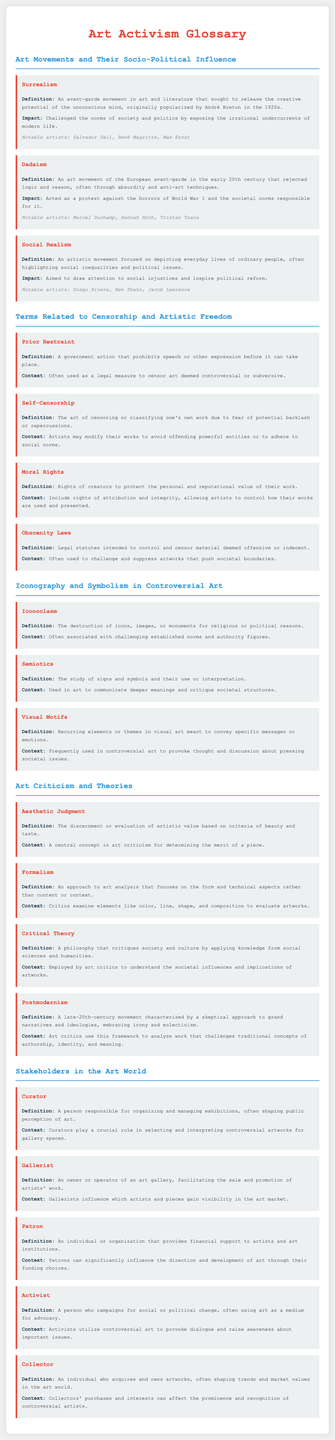What is the definition of Dadaism? Dadaism is defined as an art movement of the European avant-garde in the early 20th century that rejected logic and reason, often through absurdity and anti-art techniques.
Answer: An art movement of the European avant-garde in the early 20th century that rejected logic and reason, often through absurdity and anti-art techniques Who are notable artists associated with Surrealism? The document lists notable Surrealism artists including Salvador Dalí, René Magritte, and Max Ernst.
Answer: Salvador Dalí, René Magritte, Max Ernst What impact did Social Realism aim to achieve? Social Realism aimed to draw attention to social injustices and inspire political reform.
Answer: Draw attention to social injustices and inspire political reform What is prior restraint? Prior restraint is defined as a government action that prohibits speech or other expression before it can take place.
Answer: A government action that prohibits speech or other expression before it can take place What does moral rights protect? Moral rights protect the personal and reputational value of creators' work.
Answer: The personal and reputational value of their work What is the study of signs and symbols called? The study of signs and symbols is known as semiotics.
Answer: Semiotics How does critical theory relate to art? Critical theory is a philosophy that critiques society and culture by applying knowledge from social sciences and humanities, used by art critics to understand societal influences on artworks.
Answer: It critiques society and culture using knowledge from social sciences and humanities Who organizes and manages exhibitions in the art world? A curator is responsible for organizing and managing exhibitions.
Answer: A curator What role do collectors play in the art world? Collectors acquire and own artworks, often shaping trends and market values.
Answer: Acquire and own artworks, shaping trends and market values 